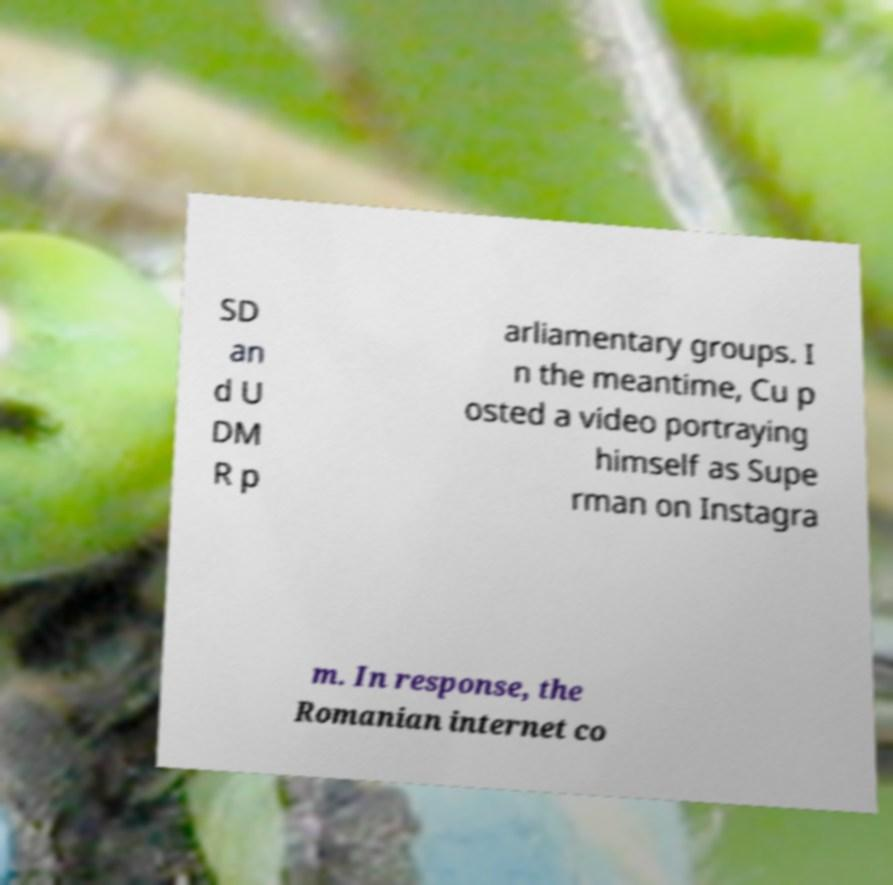There's text embedded in this image that I need extracted. Can you transcribe it verbatim? SD an d U DM R p arliamentary groups. I n the meantime, Cu p osted a video portraying himself as Supe rman on Instagra m. In response, the Romanian internet co 